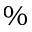<formula> <loc_0><loc_0><loc_500><loc_500>\%</formula> 